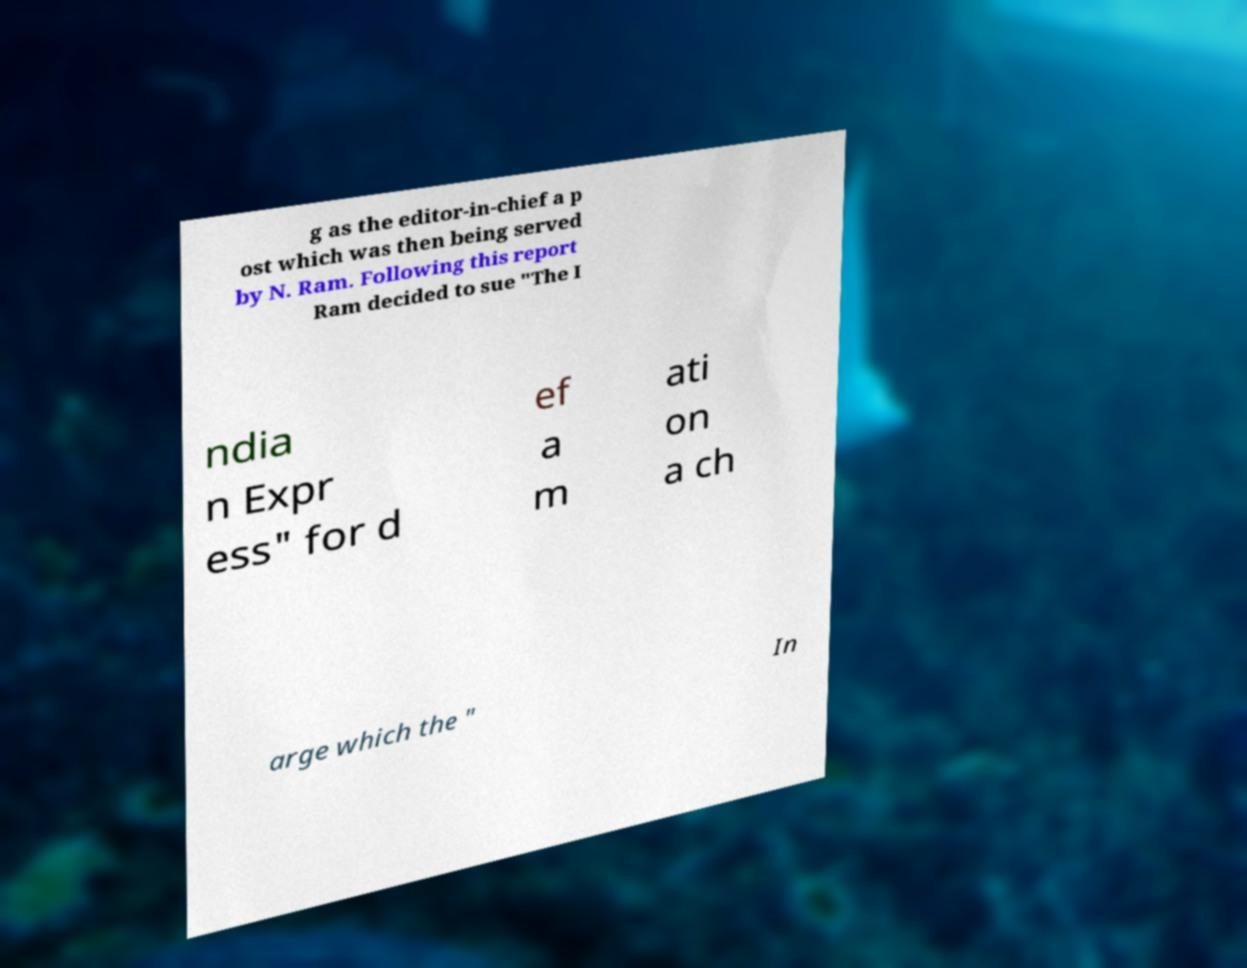There's text embedded in this image that I need extracted. Can you transcribe it verbatim? g as the editor-in-chief a p ost which was then being served by N. Ram. Following this report Ram decided to sue "The I ndia n Expr ess" for d ef a m ati on a ch arge which the " In 